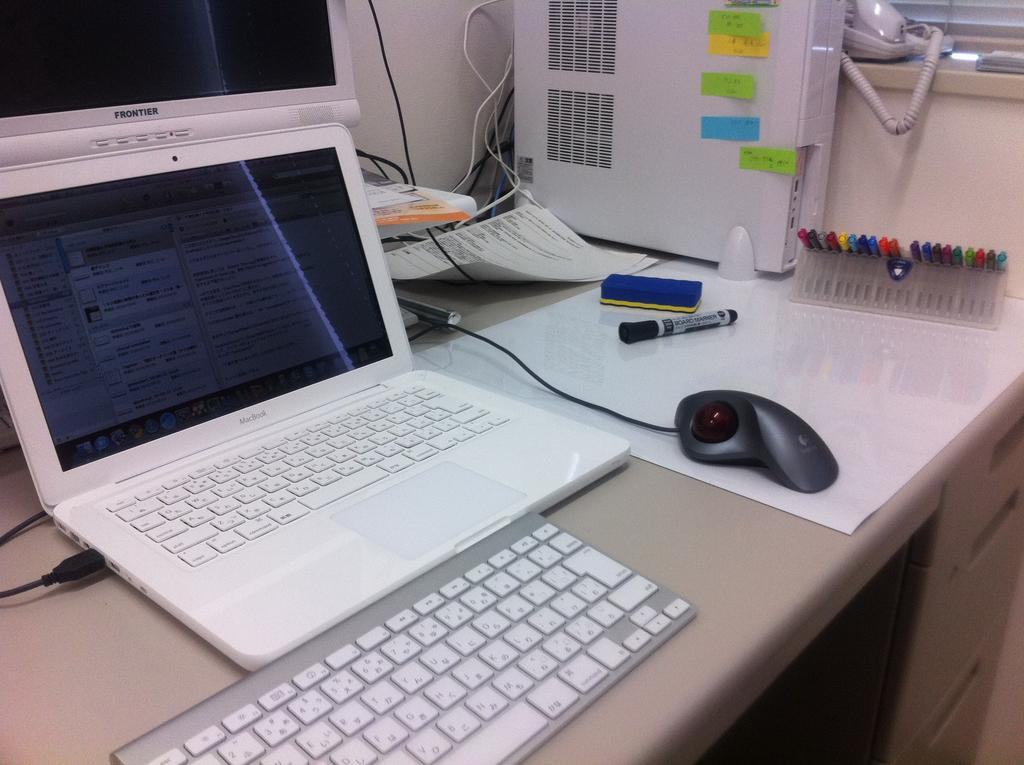What type of furniture is present in the image? There is a desk in the image. What writing instruments can be seen on the desk? There are pens and a marker on the desk. What stationery item is present on the desk? There is paper on the desk. What type of technology is present on the desk? There is a desktop computer and a laptop on the desk. What communication device is present on the desk? There is a telephone on the desk. What else can be seen on the desk? There are cables and various objects on the desk. What type of flower is present on the desk in the image? There is no flower present on the desk in the image. Is there a knife visible on the desk in the image? There is no knife present on the desk in the image. 